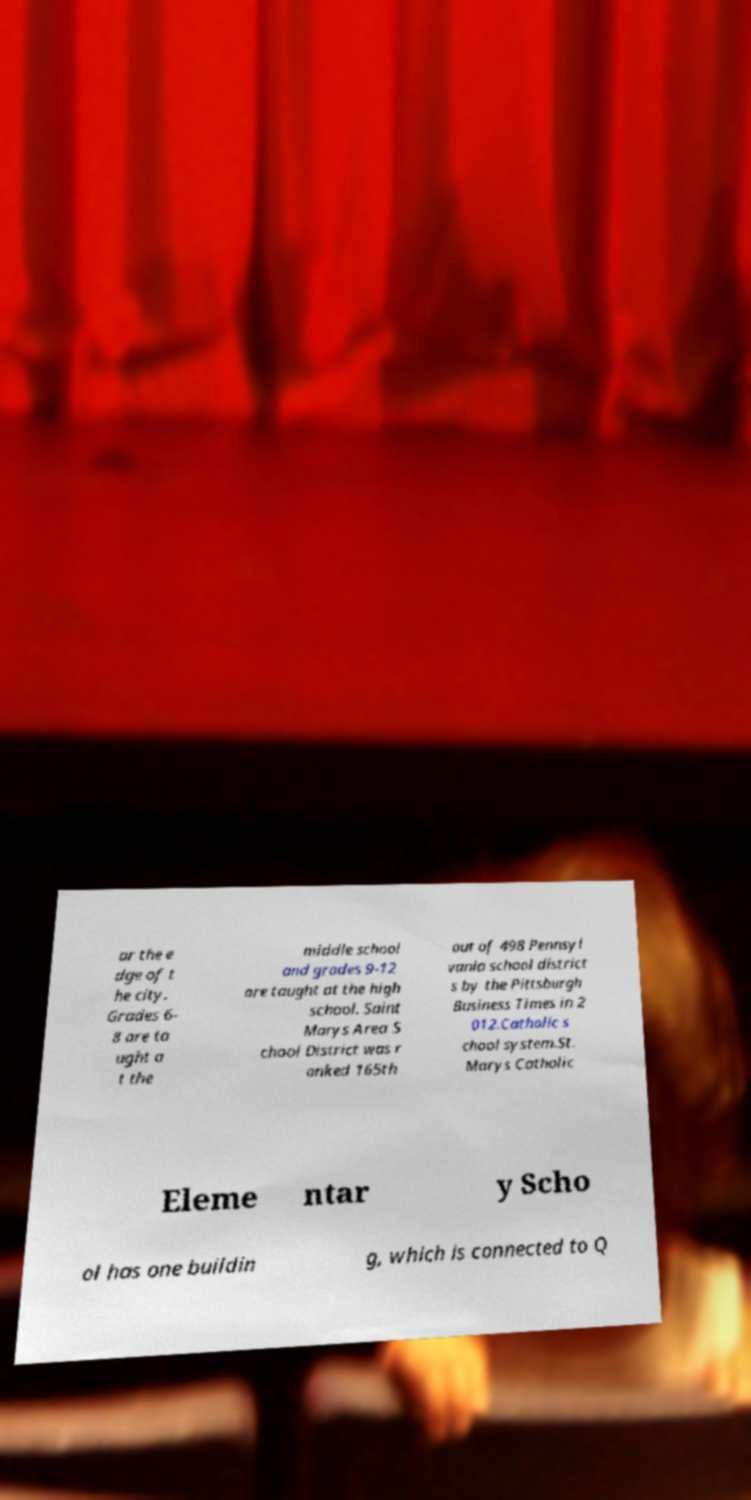Could you extract and type out the text from this image? ar the e dge of t he city. Grades 6- 8 are ta ught a t the middle school and grades 9-12 are taught at the high school. Saint Marys Area S chool District was r anked 165th out of 498 Pennsyl vania school district s by the Pittsburgh Business Times in 2 012.Catholic s chool system.St. Marys Catholic Eleme ntar y Scho ol has one buildin g, which is connected to Q 